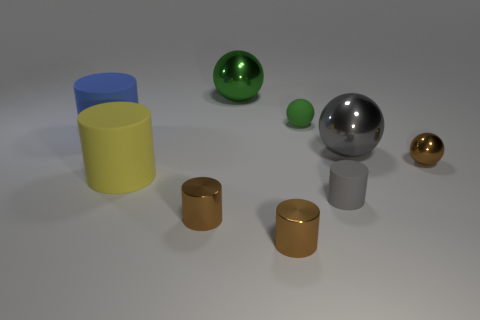Are there any other things that are the same size as the brown metallic ball?
Provide a short and direct response. Yes. What size is the green object that is made of the same material as the big gray object?
Offer a very short reply. Large. What number of objects are either large balls right of the tiny gray rubber cylinder or brown objects that are on the left side of the rubber ball?
Keep it short and to the point. 3. Does the shiny thing that is behind the blue rubber cylinder have the same size as the gray rubber cylinder?
Provide a short and direct response. No. What color is the matte cylinder that is in front of the large yellow object?
Your response must be concise. Gray. What is the color of the tiny matte object that is the same shape as the big gray object?
Provide a short and direct response. Green. There is a small sphere that is behind the large object on the left side of the yellow matte thing; how many gray spheres are behind it?
Your answer should be compact. 0. Are there any other things that have the same material as the yellow thing?
Your answer should be compact. Yes. Is the number of big metallic balls that are in front of the big gray metallic ball less than the number of blue cylinders?
Your answer should be very brief. Yes. Is the color of the tiny matte cylinder the same as the tiny rubber sphere?
Keep it short and to the point. No. 